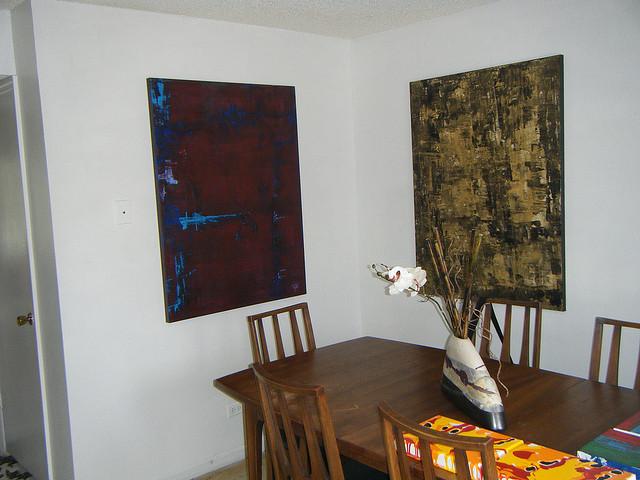Is this a colorful room?
Write a very short answer. Yes. How many chairs are seen in the picture?
Be succinct. 5. What color is the table?
Concise answer only. Brown. What is the painting of?
Keep it brief. Abstract. Is the artwork on the walls considered abstract art?
Keep it brief. Yes. Is this a child's room?
Answer briefly. No. 